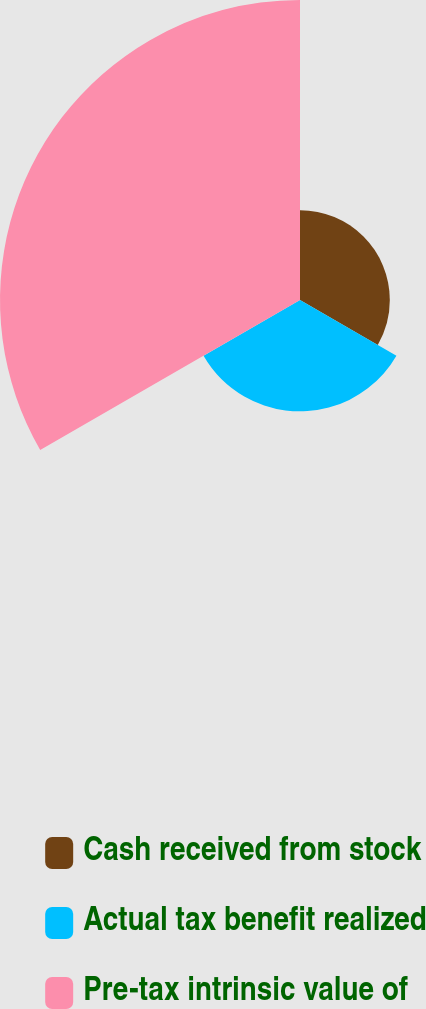<chart> <loc_0><loc_0><loc_500><loc_500><pie_chart><fcel>Cash received from stock<fcel>Actual tax benefit realized<fcel>Pre-tax intrinsic value of<nl><fcel>17.92%<fcel>22.22%<fcel>59.86%<nl></chart> 